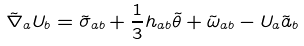Convert formula to latex. <formula><loc_0><loc_0><loc_500><loc_500>\tilde { \nabla } _ { a } U _ { b } = \tilde { \sigma } _ { a b } + \frac { 1 } { 3 } h _ { a b } \tilde { \theta } + \tilde { \omega } _ { a b } - U _ { a } \tilde { a } _ { b }</formula> 